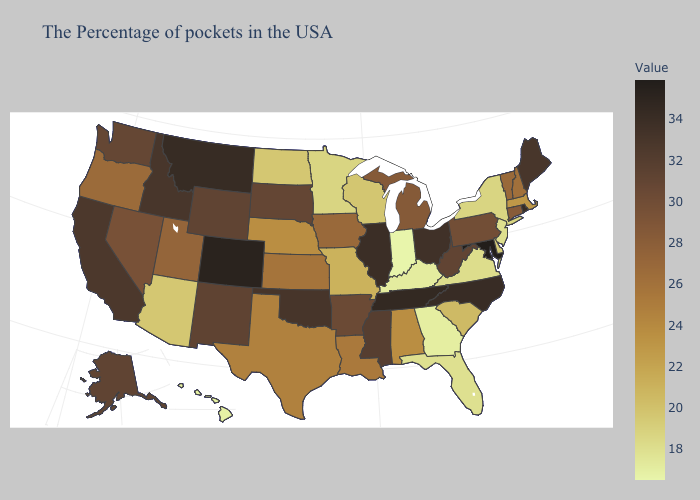Does Arkansas have the lowest value in the South?
Concise answer only. No. Does Mississippi have the lowest value in the USA?
Answer briefly. No. Is the legend a continuous bar?
Give a very brief answer. Yes. Does the map have missing data?
Keep it brief. No. Among the states that border South Carolina , which have the lowest value?
Give a very brief answer. Georgia. 